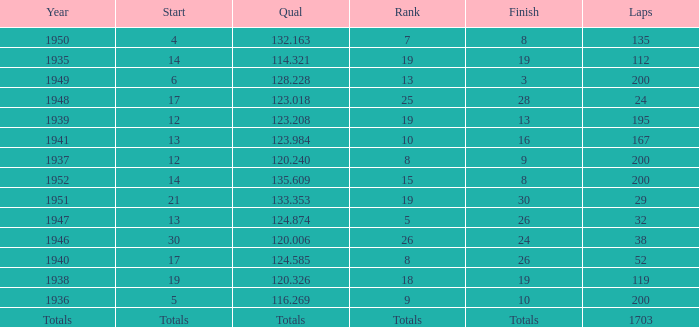In 1937, what was the finish? 9.0. 